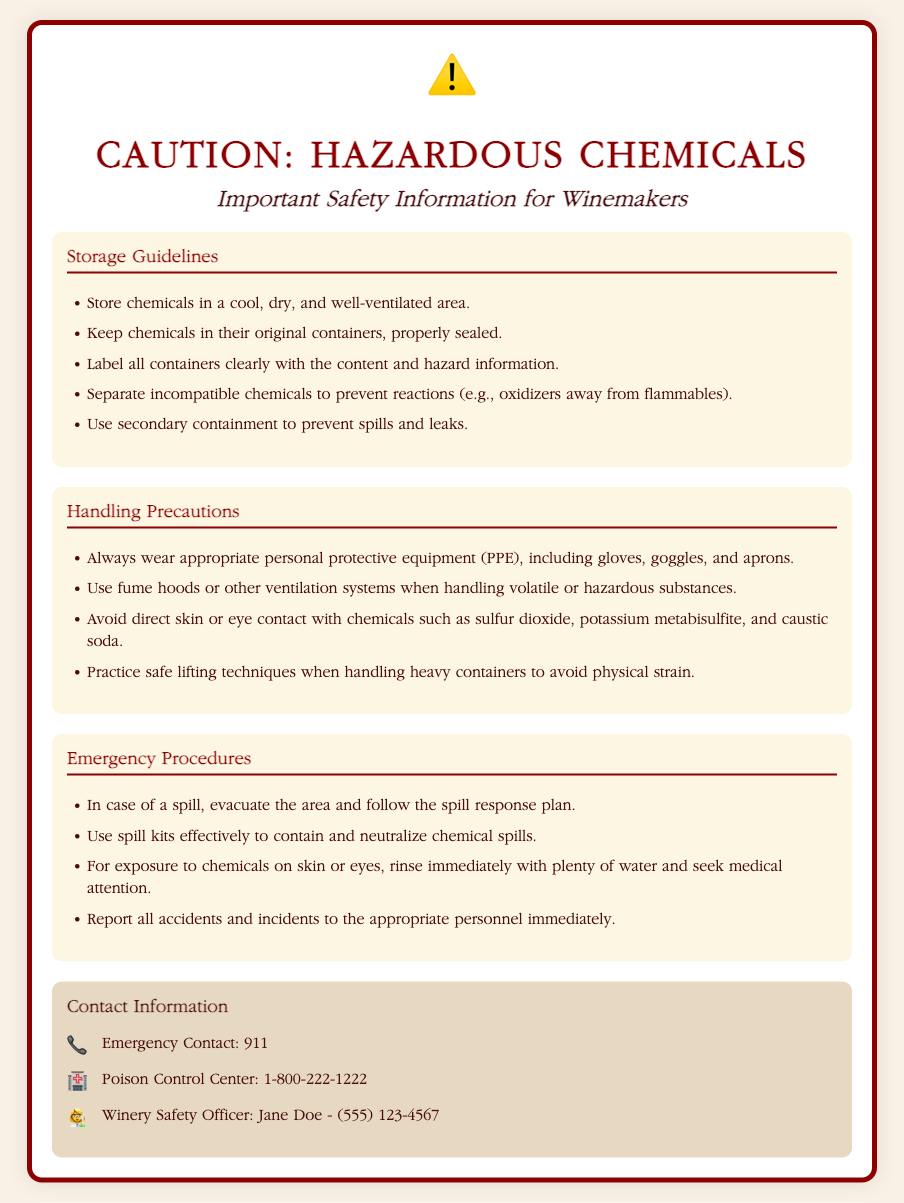What should be worn when handling chemicals? The document specifies wearing appropriate personal protective equipment (PPE), which includes gloves, goggles, and aprons.
Answer: PPE Where should chemicals be stored? The document states that chemicals should be stored in a cool, dry, and well-ventilated area.
Answer: Cool, dry, and well-ventilated area What is the emergency contact number provided? The emergency contact number listed in the document is 911.
Answer: 911 What type of chemicals should be stored away from flammables? The document advises separating incompatible chemicals, specifically mentioning oxidizers to be stored away from flammables.
Answer: Oxidizers What should be done in case of chemical exposure to skin? The document instructs to rinse immediately with plenty of water and seek medical attention.
Answer: Rinse and seek medical attention What is the primary purpose of the document? This warning label provides important safety information and guidelines for handling and storing hazardous chemicals in winemaking.
Answer: Safety information What should be done if there is a spill? The document states to evacuate the area and follow the spill response plan.
Answer: Evacuate and follow spill response plan How are containers of chemicals to be labeled? The document requires all containers to be labeled clearly with the content and hazard information.
Answer: Clearly labeled with content and hazard information 